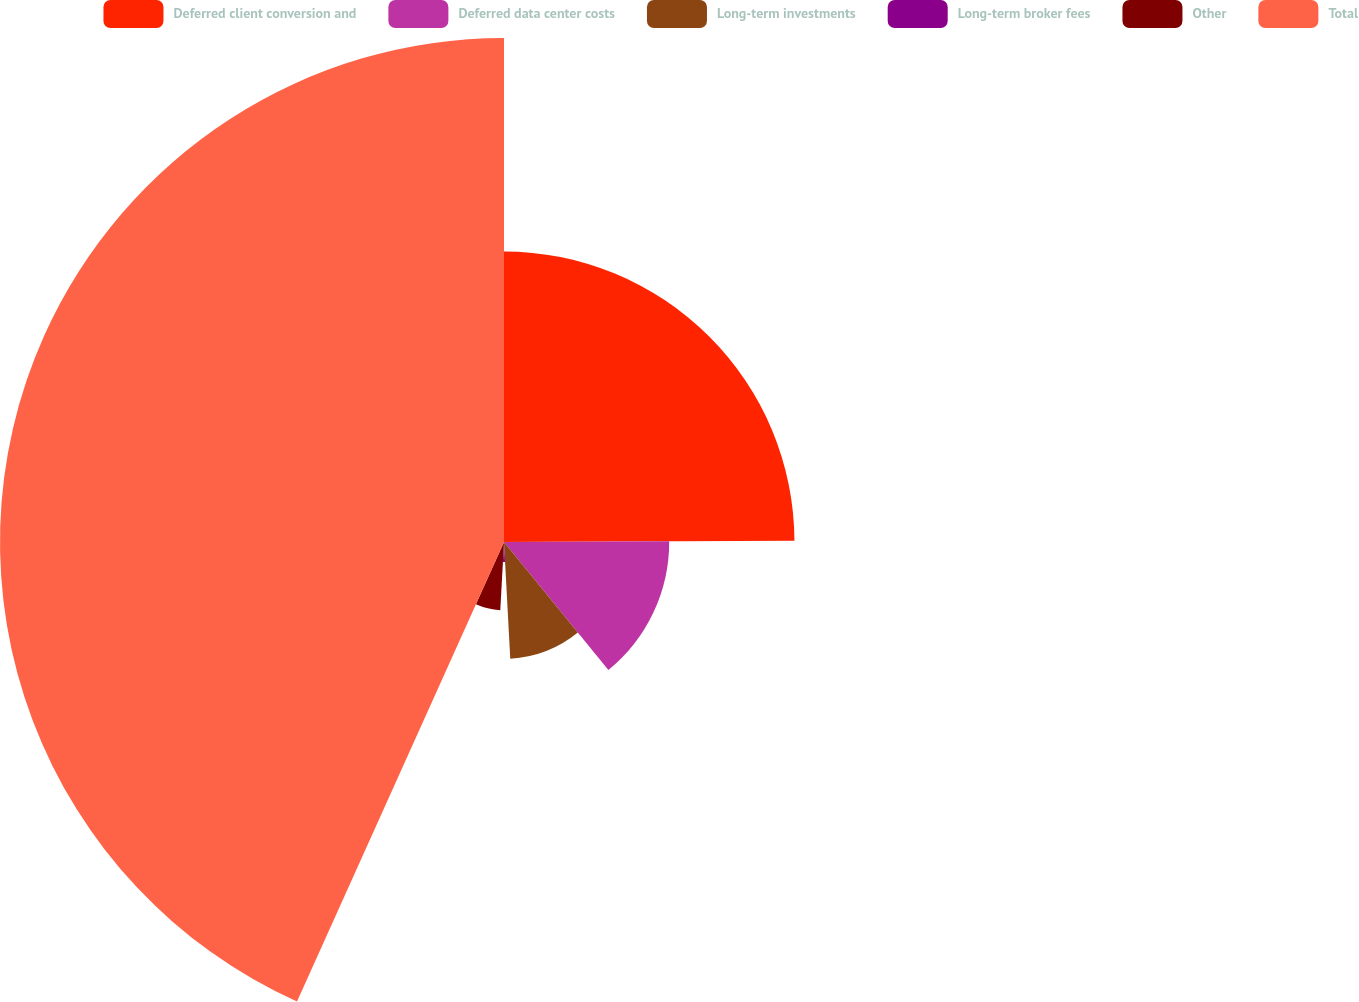<chart> <loc_0><loc_0><loc_500><loc_500><pie_chart><fcel>Deferred client conversion and<fcel>Deferred data center costs<fcel>Long-term investments<fcel>Long-term broker fees<fcel>Other<fcel>Total<nl><fcel>24.93%<fcel>14.18%<fcel>10.03%<fcel>1.72%<fcel>5.87%<fcel>43.26%<nl></chart> 